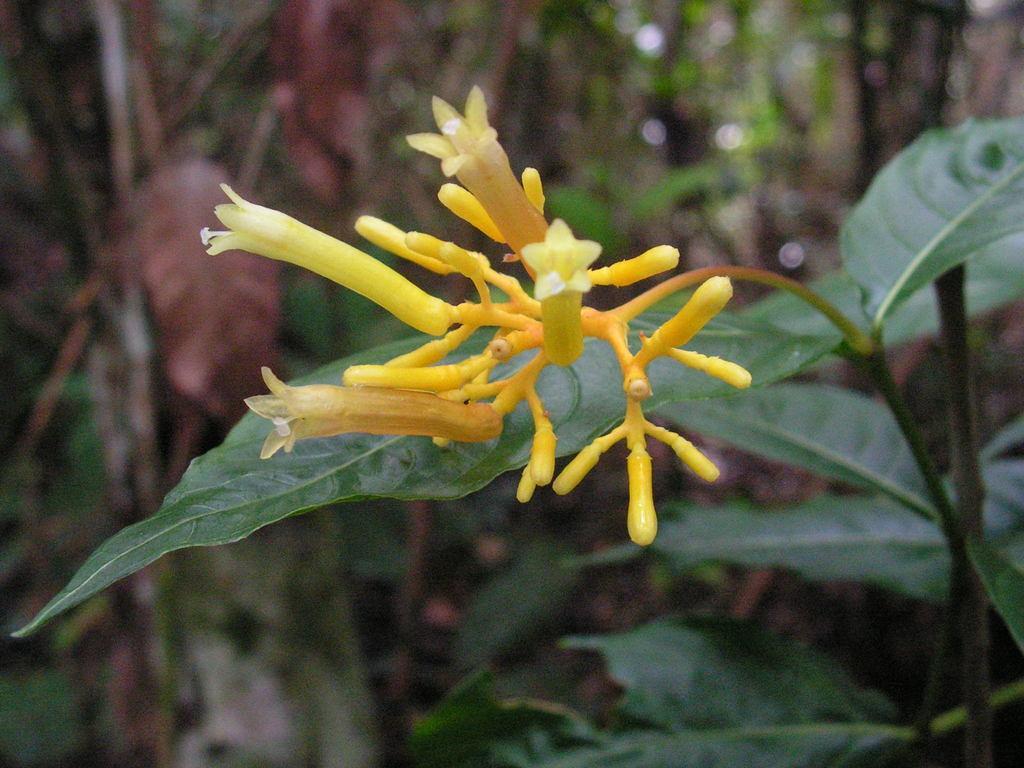In one or two sentences, can you explain what this image depicts? In this image I can see yellow color flowers and green color leaves. I can also see this image is little bit blurry from background. 